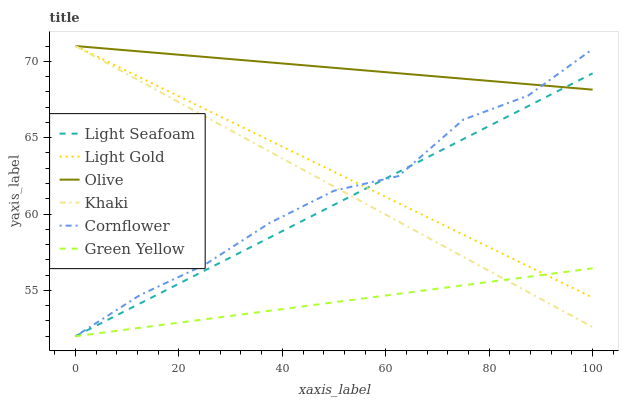Does Light Seafoam have the minimum area under the curve?
Answer yes or no. No. Does Light Seafoam have the maximum area under the curve?
Answer yes or no. No. Is Khaki the smoothest?
Answer yes or no. No. Is Khaki the roughest?
Answer yes or no. No. Does Khaki have the lowest value?
Answer yes or no. No. Does Light Seafoam have the highest value?
Answer yes or no. No. Is Green Yellow less than Olive?
Answer yes or no. Yes. Is Olive greater than Green Yellow?
Answer yes or no. Yes. Does Green Yellow intersect Olive?
Answer yes or no. No. 